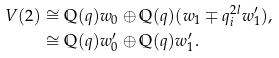Convert formula to latex. <formula><loc_0><loc_0><loc_500><loc_500>V ( 2 ) & \cong \mathbb { Q } ( q ) w _ { 0 } \oplus \mathbb { Q } ( q ) ( w _ { 1 } \mp q _ { i } ^ { 2 l } w _ { 1 } ^ { \prime } ) , \\ & \cong \mathbb { Q } ( q ) w _ { 0 } ^ { \prime } \oplus \mathbb { Q } ( q ) w _ { 1 } ^ { \prime } .</formula> 